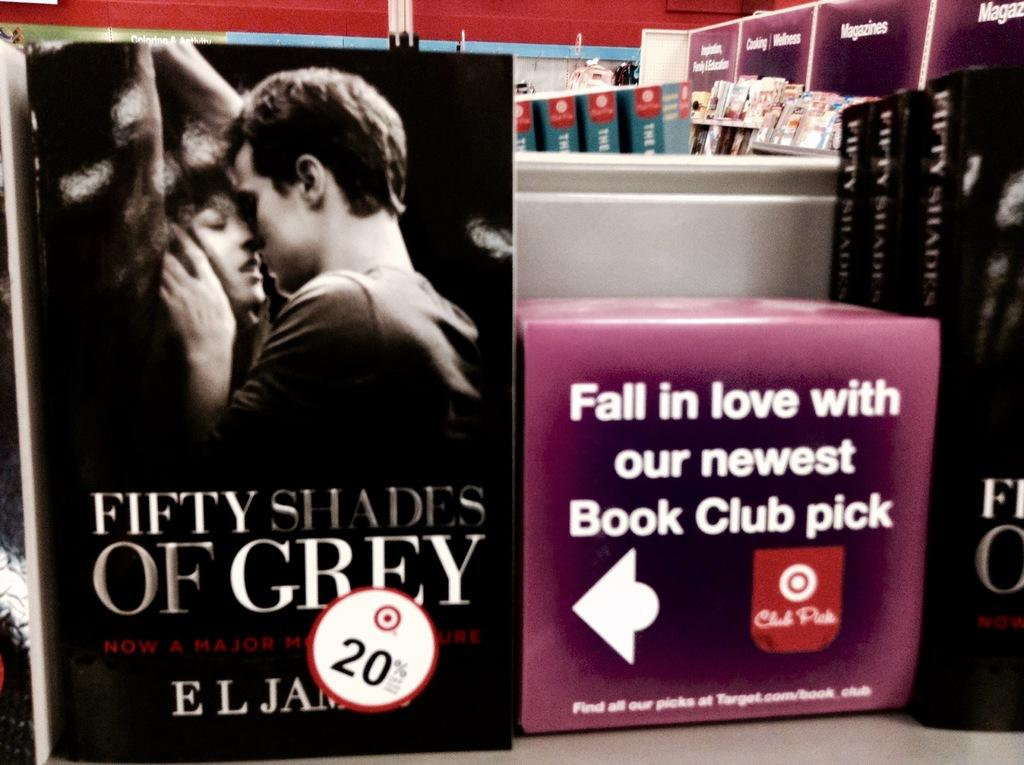<image>
Summarize the visual content of the image. A book store shelf has one called Fifty Shades of Grey on it. 